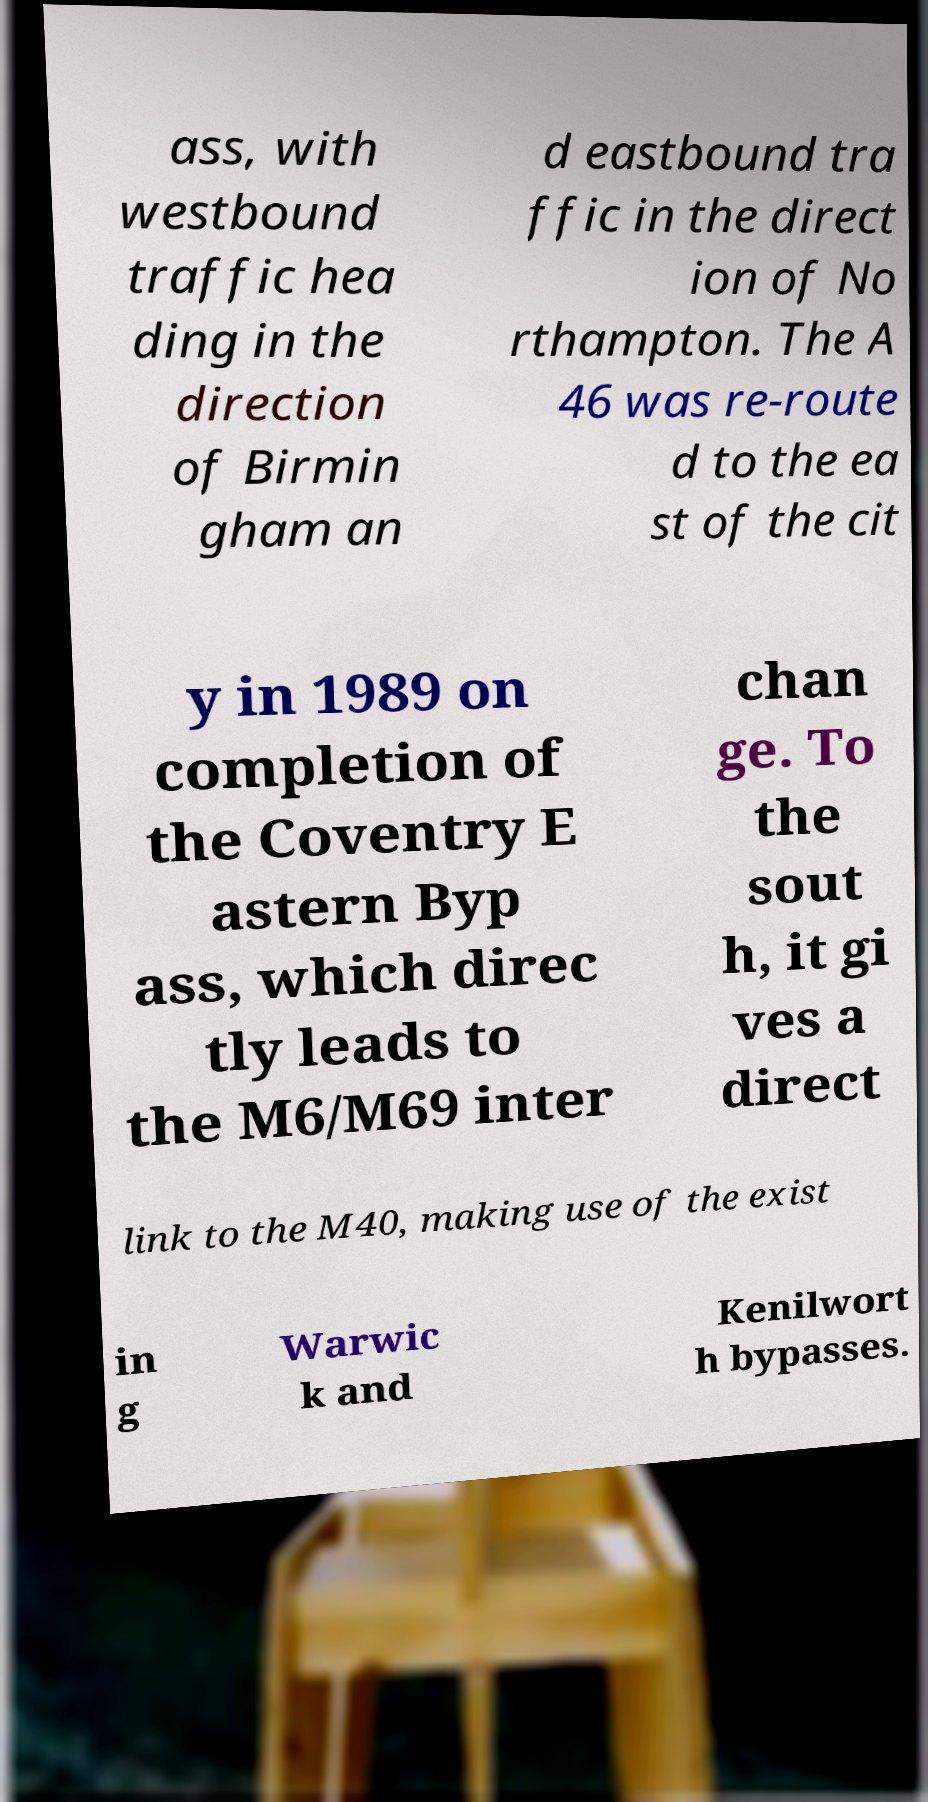Please identify and transcribe the text found in this image. ass, with westbound traffic hea ding in the direction of Birmin gham an d eastbound tra ffic in the direct ion of No rthampton. The A 46 was re-route d to the ea st of the cit y in 1989 on completion of the Coventry E astern Byp ass, which direc tly leads to the M6/M69 inter chan ge. To the sout h, it gi ves a direct link to the M40, making use of the exist in g Warwic k and Kenilwort h bypasses. 